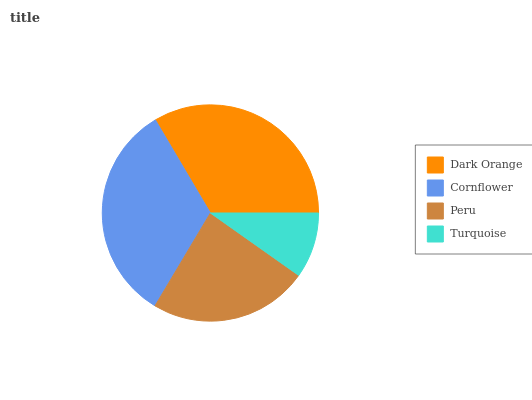Is Turquoise the minimum?
Answer yes or no. Yes. Is Dark Orange the maximum?
Answer yes or no. Yes. Is Cornflower the minimum?
Answer yes or no. No. Is Cornflower the maximum?
Answer yes or no. No. Is Dark Orange greater than Cornflower?
Answer yes or no. Yes. Is Cornflower less than Dark Orange?
Answer yes or no. Yes. Is Cornflower greater than Dark Orange?
Answer yes or no. No. Is Dark Orange less than Cornflower?
Answer yes or no. No. Is Cornflower the high median?
Answer yes or no. Yes. Is Peru the low median?
Answer yes or no. Yes. Is Turquoise the high median?
Answer yes or no. No. Is Cornflower the low median?
Answer yes or no. No. 